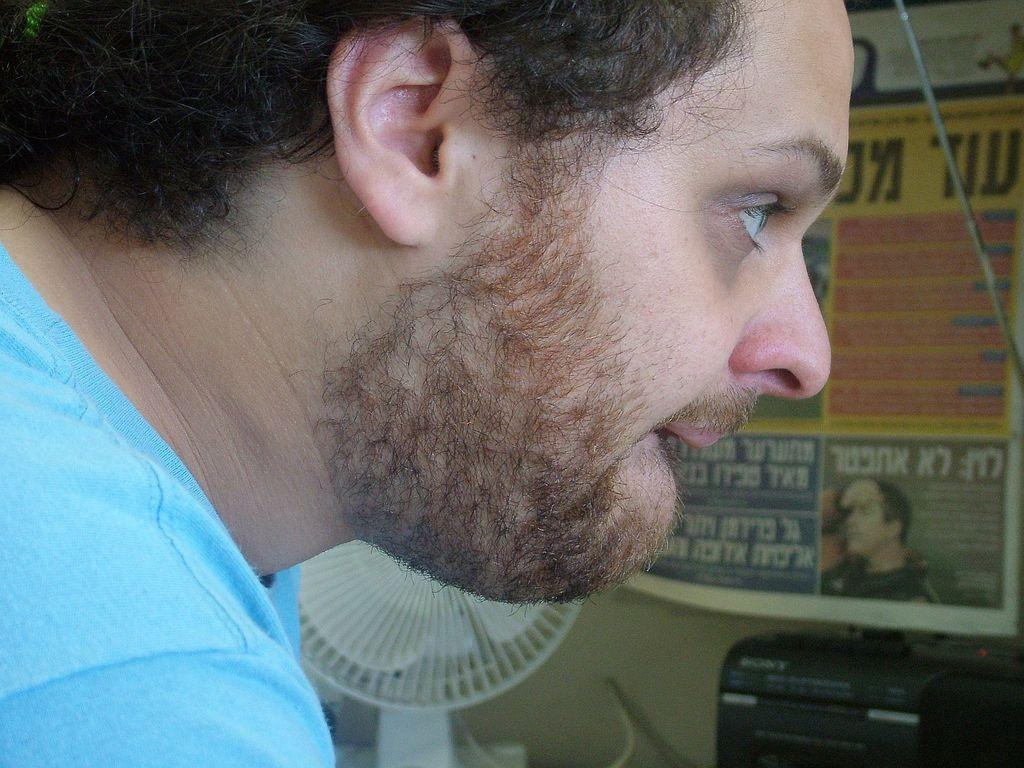What is the main subject in the image? There is a person in the image. What can be seen near the person? There is a table fan in the image. What else is visible in the image besides the person and the table fan? There are other objects in the image. What is visible in the background of the image? There is a wall in the background of the image. What is the name of the person's pet dog, which is not visible in the image? There is no pet dog mentioned or visible in the image, so we cannot determine its name. 